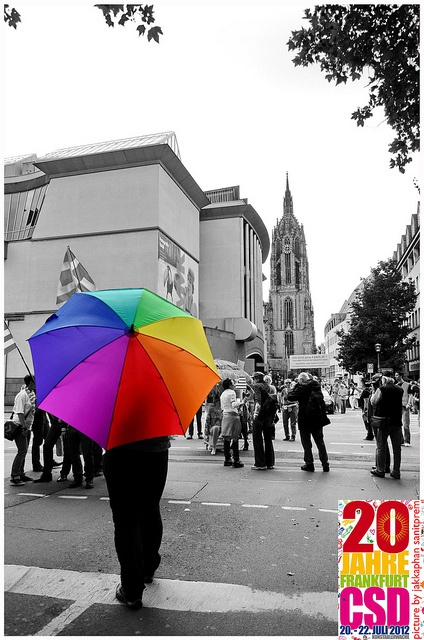Describe the objects in this image and their specific colors. I can see umbrella in white, purple, brown, red, and blue tones, people in white, black, gray, and maroon tones, people in white, black, gray, darkgray, and lightgray tones, people in white, black, gray, darkgray, and lightgray tones, and people in white, black, gray, darkgray, and lightgray tones in this image. 